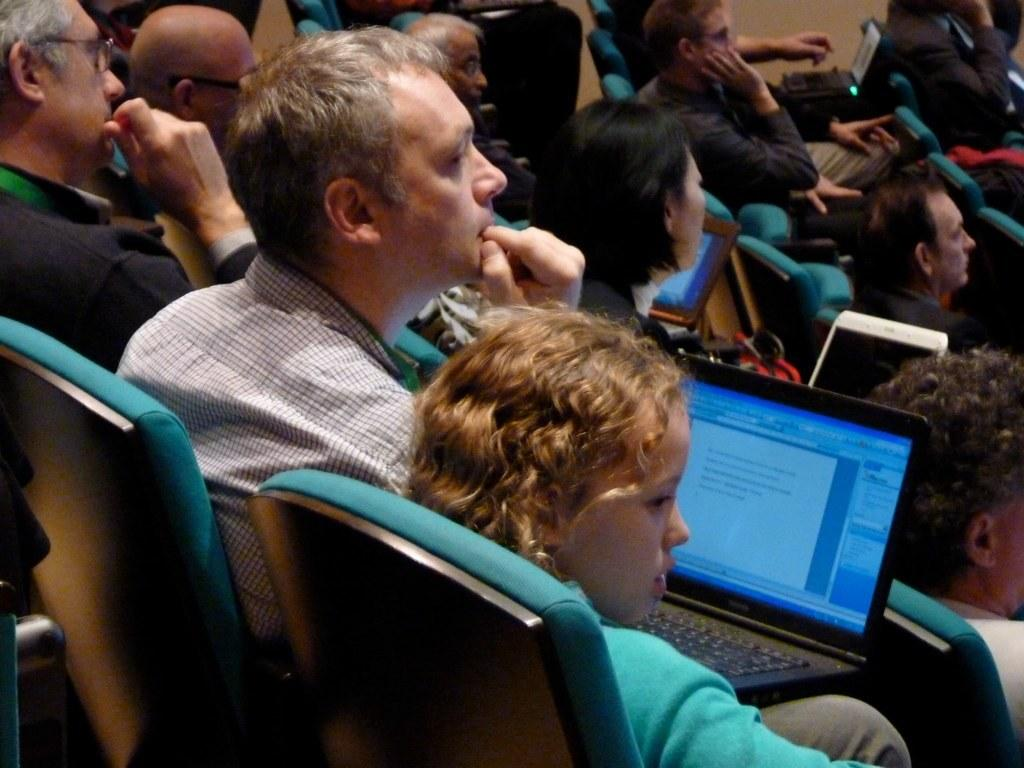What is happening in the image? There is a group of people in the image. What are the people doing in the image? The people are sitting on chairs and some of them are operating laptops. What type of jelly can be seen in the image? There is no jelly present in the image. How does the group of people show respect in the image? The image does not depict any actions related to showing respect, as it only shows people sitting on chairs and using laptops. 